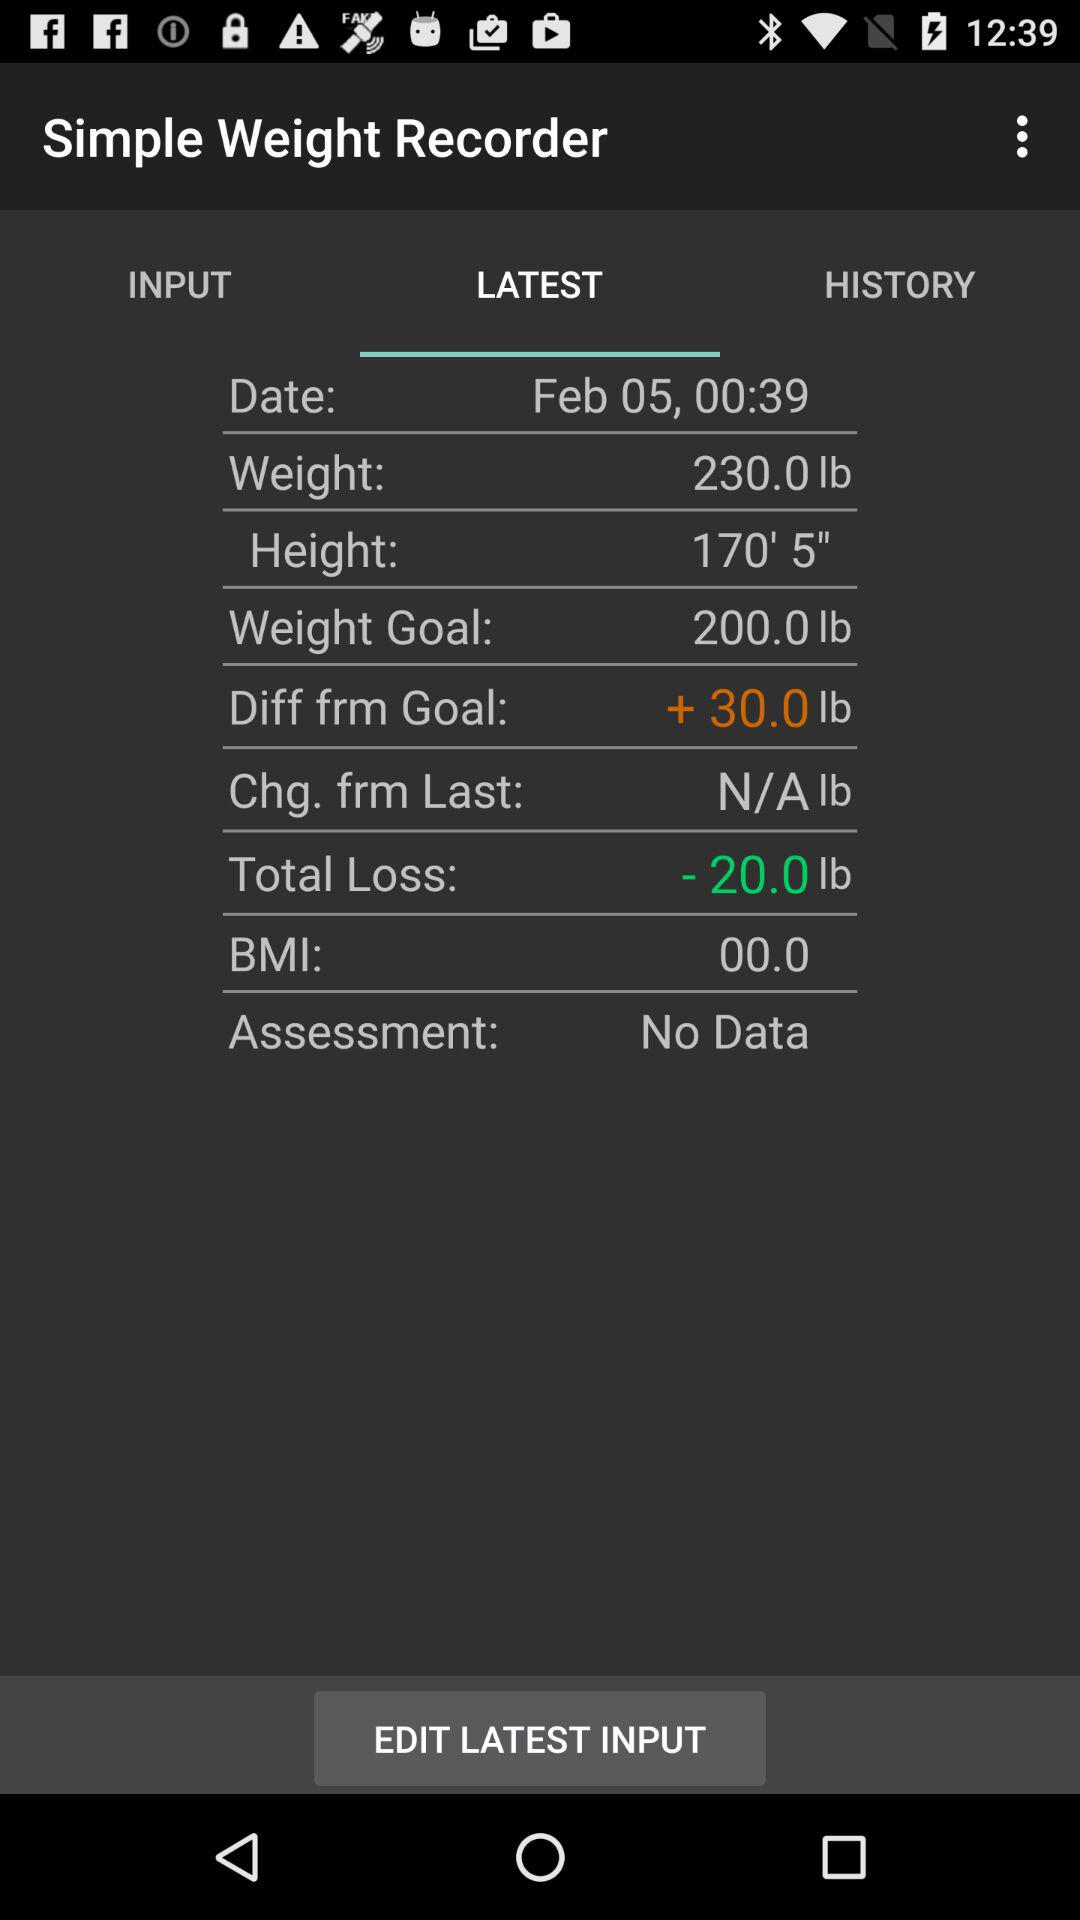What is the weight goal of the person? The weight goal of the person is 200 pounds. 